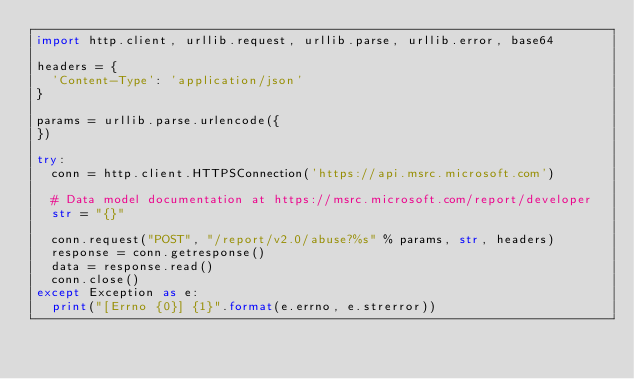<code> <loc_0><loc_0><loc_500><loc_500><_Python_>import http.client, urllib.request, urllib.parse, urllib.error, base64

headers = {
  'Content-Type': 'application/json'
}

params = urllib.parse.urlencode({
})

try:
  conn = http.client.HTTPSConnection('https://api.msrc.microsoft.com')
  
  # Data model documentation at https://msrc.microsoft.com/report/developer
  str = "{}"
  
  conn.request("POST", "/report/v2.0/abuse?%s" % params, str, headers)
  response = conn.getresponse()
  data = response.read()
  conn.close()
except Exception as e:
  print("[Errno {0}] {1}".format(e.errno, e.strerror))
</code> 